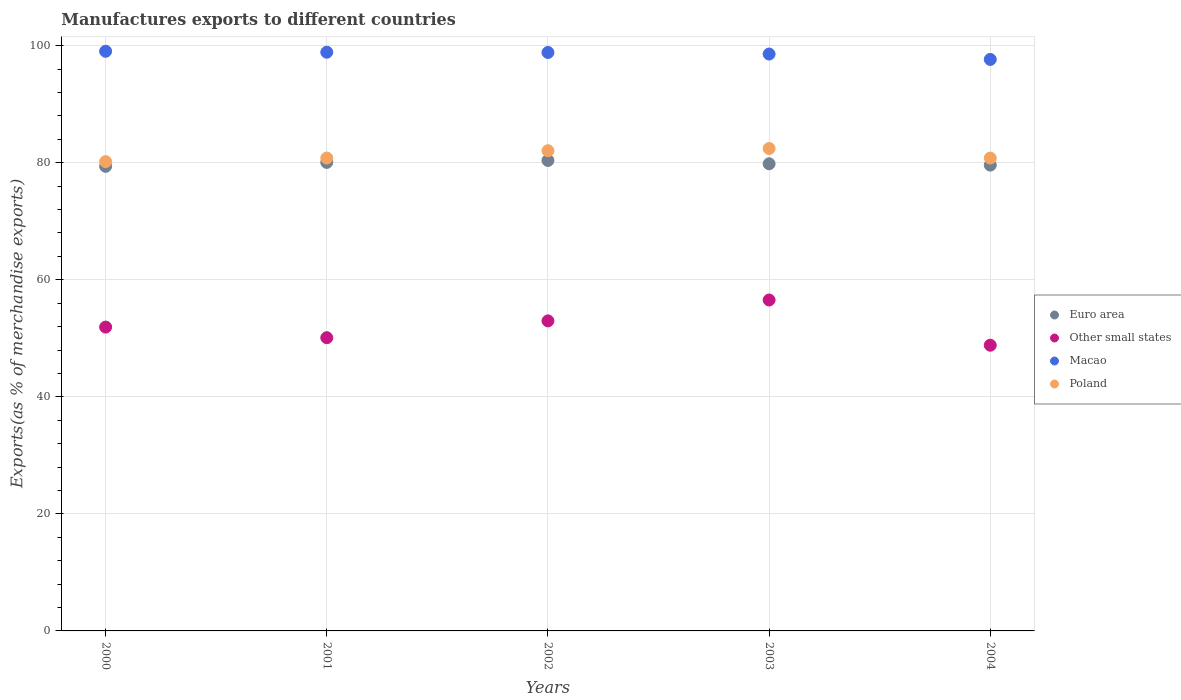Is the number of dotlines equal to the number of legend labels?
Your response must be concise. Yes. What is the percentage of exports to different countries in Macao in 2001?
Your answer should be very brief. 98.89. Across all years, what is the maximum percentage of exports to different countries in Macao?
Keep it short and to the point. 99.05. Across all years, what is the minimum percentage of exports to different countries in Euro area?
Offer a terse response. 79.39. In which year was the percentage of exports to different countries in Euro area maximum?
Provide a succinct answer. 2002. What is the total percentage of exports to different countries in Macao in the graph?
Keep it short and to the point. 493.03. What is the difference between the percentage of exports to different countries in Other small states in 2002 and that in 2004?
Keep it short and to the point. 4.16. What is the difference between the percentage of exports to different countries in Poland in 2004 and the percentage of exports to different countries in Euro area in 2001?
Your response must be concise. 0.74. What is the average percentage of exports to different countries in Macao per year?
Provide a succinct answer. 98.61. In the year 2004, what is the difference between the percentage of exports to different countries in Other small states and percentage of exports to different countries in Macao?
Make the answer very short. -48.84. In how many years, is the percentage of exports to different countries in Other small states greater than 40 %?
Make the answer very short. 5. What is the ratio of the percentage of exports to different countries in Euro area in 2002 to that in 2003?
Provide a succinct answer. 1.01. Is the percentage of exports to different countries in Euro area in 2000 less than that in 2004?
Give a very brief answer. Yes. Is the difference between the percentage of exports to different countries in Other small states in 2002 and 2004 greater than the difference between the percentage of exports to different countries in Macao in 2002 and 2004?
Ensure brevity in your answer.  Yes. What is the difference between the highest and the second highest percentage of exports to different countries in Euro area?
Give a very brief answer. 0.34. What is the difference between the highest and the lowest percentage of exports to different countries in Euro area?
Your answer should be compact. 1.01. In how many years, is the percentage of exports to different countries in Macao greater than the average percentage of exports to different countries in Macao taken over all years?
Give a very brief answer. 3. Is the sum of the percentage of exports to different countries in Macao in 2002 and 2004 greater than the maximum percentage of exports to different countries in Other small states across all years?
Keep it short and to the point. Yes. Is it the case that in every year, the sum of the percentage of exports to different countries in Euro area and percentage of exports to different countries in Macao  is greater than the sum of percentage of exports to different countries in Other small states and percentage of exports to different countries in Poland?
Offer a very short reply. No. Is it the case that in every year, the sum of the percentage of exports to different countries in Poland and percentage of exports to different countries in Macao  is greater than the percentage of exports to different countries in Euro area?
Provide a succinct answer. Yes. Does the percentage of exports to different countries in Other small states monotonically increase over the years?
Your answer should be very brief. No. Is the percentage of exports to different countries in Poland strictly less than the percentage of exports to different countries in Other small states over the years?
Keep it short and to the point. No. How many years are there in the graph?
Make the answer very short. 5. Does the graph contain grids?
Provide a short and direct response. Yes. How many legend labels are there?
Your answer should be very brief. 4. How are the legend labels stacked?
Your answer should be compact. Vertical. What is the title of the graph?
Make the answer very short. Manufactures exports to different countries. Does "Lao PDR" appear as one of the legend labels in the graph?
Give a very brief answer. No. What is the label or title of the X-axis?
Offer a terse response. Years. What is the label or title of the Y-axis?
Provide a succinct answer. Exports(as % of merchandise exports). What is the Exports(as % of merchandise exports) of Euro area in 2000?
Offer a terse response. 79.39. What is the Exports(as % of merchandise exports) in Other small states in 2000?
Your answer should be very brief. 51.92. What is the Exports(as % of merchandise exports) of Macao in 2000?
Make the answer very short. 99.05. What is the Exports(as % of merchandise exports) in Poland in 2000?
Give a very brief answer. 80.19. What is the Exports(as % of merchandise exports) in Euro area in 2001?
Give a very brief answer. 80.06. What is the Exports(as % of merchandise exports) in Other small states in 2001?
Offer a very short reply. 50.11. What is the Exports(as % of merchandise exports) of Macao in 2001?
Ensure brevity in your answer.  98.89. What is the Exports(as % of merchandise exports) of Poland in 2001?
Make the answer very short. 80.81. What is the Exports(as % of merchandise exports) of Euro area in 2002?
Your answer should be very brief. 80.4. What is the Exports(as % of merchandise exports) of Other small states in 2002?
Offer a very short reply. 52.98. What is the Exports(as % of merchandise exports) of Macao in 2002?
Provide a short and direct response. 98.85. What is the Exports(as % of merchandise exports) of Poland in 2002?
Offer a terse response. 82.06. What is the Exports(as % of merchandise exports) of Euro area in 2003?
Your answer should be compact. 79.83. What is the Exports(as % of merchandise exports) of Other small states in 2003?
Offer a very short reply. 56.55. What is the Exports(as % of merchandise exports) in Macao in 2003?
Your answer should be very brief. 98.58. What is the Exports(as % of merchandise exports) in Poland in 2003?
Ensure brevity in your answer.  82.44. What is the Exports(as % of merchandise exports) of Euro area in 2004?
Your response must be concise. 79.6. What is the Exports(as % of merchandise exports) in Other small states in 2004?
Keep it short and to the point. 48.82. What is the Exports(as % of merchandise exports) in Macao in 2004?
Your answer should be very brief. 97.66. What is the Exports(as % of merchandise exports) of Poland in 2004?
Your answer should be very brief. 80.8. Across all years, what is the maximum Exports(as % of merchandise exports) of Euro area?
Give a very brief answer. 80.4. Across all years, what is the maximum Exports(as % of merchandise exports) in Other small states?
Offer a terse response. 56.55. Across all years, what is the maximum Exports(as % of merchandise exports) in Macao?
Give a very brief answer. 99.05. Across all years, what is the maximum Exports(as % of merchandise exports) of Poland?
Provide a succinct answer. 82.44. Across all years, what is the minimum Exports(as % of merchandise exports) of Euro area?
Your response must be concise. 79.39. Across all years, what is the minimum Exports(as % of merchandise exports) in Other small states?
Provide a succinct answer. 48.82. Across all years, what is the minimum Exports(as % of merchandise exports) of Macao?
Ensure brevity in your answer.  97.66. Across all years, what is the minimum Exports(as % of merchandise exports) in Poland?
Provide a short and direct response. 80.19. What is the total Exports(as % of merchandise exports) in Euro area in the graph?
Offer a very short reply. 399.27. What is the total Exports(as % of merchandise exports) of Other small states in the graph?
Your answer should be very brief. 260.38. What is the total Exports(as % of merchandise exports) of Macao in the graph?
Provide a succinct answer. 493.03. What is the total Exports(as % of merchandise exports) of Poland in the graph?
Your answer should be compact. 406.3. What is the difference between the Exports(as % of merchandise exports) in Euro area in 2000 and that in 2001?
Make the answer very short. -0.67. What is the difference between the Exports(as % of merchandise exports) of Other small states in 2000 and that in 2001?
Your answer should be compact. 1.81. What is the difference between the Exports(as % of merchandise exports) in Macao in 2000 and that in 2001?
Your answer should be compact. 0.16. What is the difference between the Exports(as % of merchandise exports) in Poland in 2000 and that in 2001?
Offer a very short reply. -0.62. What is the difference between the Exports(as % of merchandise exports) of Euro area in 2000 and that in 2002?
Offer a terse response. -1.01. What is the difference between the Exports(as % of merchandise exports) in Other small states in 2000 and that in 2002?
Give a very brief answer. -1.06. What is the difference between the Exports(as % of merchandise exports) of Macao in 2000 and that in 2002?
Your response must be concise. 0.2. What is the difference between the Exports(as % of merchandise exports) in Poland in 2000 and that in 2002?
Give a very brief answer. -1.87. What is the difference between the Exports(as % of merchandise exports) in Euro area in 2000 and that in 2003?
Keep it short and to the point. -0.44. What is the difference between the Exports(as % of merchandise exports) in Other small states in 2000 and that in 2003?
Keep it short and to the point. -4.63. What is the difference between the Exports(as % of merchandise exports) in Macao in 2000 and that in 2003?
Provide a succinct answer. 0.47. What is the difference between the Exports(as % of merchandise exports) of Poland in 2000 and that in 2003?
Provide a succinct answer. -2.24. What is the difference between the Exports(as % of merchandise exports) in Euro area in 2000 and that in 2004?
Make the answer very short. -0.21. What is the difference between the Exports(as % of merchandise exports) of Other small states in 2000 and that in 2004?
Your answer should be very brief. 3.1. What is the difference between the Exports(as % of merchandise exports) in Macao in 2000 and that in 2004?
Make the answer very short. 1.39. What is the difference between the Exports(as % of merchandise exports) of Poland in 2000 and that in 2004?
Your answer should be compact. -0.61. What is the difference between the Exports(as % of merchandise exports) in Euro area in 2001 and that in 2002?
Your answer should be very brief. -0.34. What is the difference between the Exports(as % of merchandise exports) of Other small states in 2001 and that in 2002?
Ensure brevity in your answer.  -2.87. What is the difference between the Exports(as % of merchandise exports) in Macao in 2001 and that in 2002?
Keep it short and to the point. 0.04. What is the difference between the Exports(as % of merchandise exports) in Poland in 2001 and that in 2002?
Give a very brief answer. -1.25. What is the difference between the Exports(as % of merchandise exports) in Euro area in 2001 and that in 2003?
Your answer should be compact. 0.24. What is the difference between the Exports(as % of merchandise exports) in Other small states in 2001 and that in 2003?
Offer a very short reply. -6.44. What is the difference between the Exports(as % of merchandise exports) of Macao in 2001 and that in 2003?
Keep it short and to the point. 0.31. What is the difference between the Exports(as % of merchandise exports) of Poland in 2001 and that in 2003?
Your answer should be compact. -1.63. What is the difference between the Exports(as % of merchandise exports) of Euro area in 2001 and that in 2004?
Provide a succinct answer. 0.46. What is the difference between the Exports(as % of merchandise exports) in Other small states in 2001 and that in 2004?
Offer a terse response. 1.29. What is the difference between the Exports(as % of merchandise exports) of Macao in 2001 and that in 2004?
Make the answer very short. 1.23. What is the difference between the Exports(as % of merchandise exports) of Poland in 2001 and that in 2004?
Offer a terse response. 0.01. What is the difference between the Exports(as % of merchandise exports) in Euro area in 2002 and that in 2003?
Offer a very short reply. 0.57. What is the difference between the Exports(as % of merchandise exports) in Other small states in 2002 and that in 2003?
Your answer should be very brief. -3.57. What is the difference between the Exports(as % of merchandise exports) of Macao in 2002 and that in 2003?
Ensure brevity in your answer.  0.27. What is the difference between the Exports(as % of merchandise exports) in Poland in 2002 and that in 2003?
Offer a very short reply. -0.38. What is the difference between the Exports(as % of merchandise exports) of Euro area in 2002 and that in 2004?
Your answer should be compact. 0.8. What is the difference between the Exports(as % of merchandise exports) in Other small states in 2002 and that in 2004?
Offer a very short reply. 4.16. What is the difference between the Exports(as % of merchandise exports) in Macao in 2002 and that in 2004?
Your answer should be very brief. 1.19. What is the difference between the Exports(as % of merchandise exports) in Poland in 2002 and that in 2004?
Keep it short and to the point. 1.26. What is the difference between the Exports(as % of merchandise exports) of Euro area in 2003 and that in 2004?
Offer a terse response. 0.23. What is the difference between the Exports(as % of merchandise exports) of Other small states in 2003 and that in 2004?
Provide a succinct answer. 7.73. What is the difference between the Exports(as % of merchandise exports) in Macao in 2003 and that in 2004?
Your response must be concise. 0.92. What is the difference between the Exports(as % of merchandise exports) of Poland in 2003 and that in 2004?
Your answer should be compact. 1.64. What is the difference between the Exports(as % of merchandise exports) of Euro area in 2000 and the Exports(as % of merchandise exports) of Other small states in 2001?
Offer a terse response. 29.28. What is the difference between the Exports(as % of merchandise exports) in Euro area in 2000 and the Exports(as % of merchandise exports) in Macao in 2001?
Ensure brevity in your answer.  -19.5. What is the difference between the Exports(as % of merchandise exports) in Euro area in 2000 and the Exports(as % of merchandise exports) in Poland in 2001?
Offer a terse response. -1.42. What is the difference between the Exports(as % of merchandise exports) in Other small states in 2000 and the Exports(as % of merchandise exports) in Macao in 2001?
Your answer should be compact. -46.97. What is the difference between the Exports(as % of merchandise exports) of Other small states in 2000 and the Exports(as % of merchandise exports) of Poland in 2001?
Make the answer very short. -28.89. What is the difference between the Exports(as % of merchandise exports) of Macao in 2000 and the Exports(as % of merchandise exports) of Poland in 2001?
Your response must be concise. 18.24. What is the difference between the Exports(as % of merchandise exports) of Euro area in 2000 and the Exports(as % of merchandise exports) of Other small states in 2002?
Offer a very short reply. 26.41. What is the difference between the Exports(as % of merchandise exports) of Euro area in 2000 and the Exports(as % of merchandise exports) of Macao in 2002?
Keep it short and to the point. -19.46. What is the difference between the Exports(as % of merchandise exports) in Euro area in 2000 and the Exports(as % of merchandise exports) in Poland in 2002?
Keep it short and to the point. -2.67. What is the difference between the Exports(as % of merchandise exports) of Other small states in 2000 and the Exports(as % of merchandise exports) of Macao in 2002?
Offer a terse response. -46.93. What is the difference between the Exports(as % of merchandise exports) in Other small states in 2000 and the Exports(as % of merchandise exports) in Poland in 2002?
Give a very brief answer. -30.14. What is the difference between the Exports(as % of merchandise exports) of Macao in 2000 and the Exports(as % of merchandise exports) of Poland in 2002?
Offer a very short reply. 16.99. What is the difference between the Exports(as % of merchandise exports) in Euro area in 2000 and the Exports(as % of merchandise exports) in Other small states in 2003?
Offer a very short reply. 22.84. What is the difference between the Exports(as % of merchandise exports) in Euro area in 2000 and the Exports(as % of merchandise exports) in Macao in 2003?
Your response must be concise. -19.19. What is the difference between the Exports(as % of merchandise exports) in Euro area in 2000 and the Exports(as % of merchandise exports) in Poland in 2003?
Offer a terse response. -3.05. What is the difference between the Exports(as % of merchandise exports) of Other small states in 2000 and the Exports(as % of merchandise exports) of Macao in 2003?
Offer a terse response. -46.66. What is the difference between the Exports(as % of merchandise exports) in Other small states in 2000 and the Exports(as % of merchandise exports) in Poland in 2003?
Your answer should be compact. -30.52. What is the difference between the Exports(as % of merchandise exports) of Macao in 2000 and the Exports(as % of merchandise exports) of Poland in 2003?
Offer a very short reply. 16.62. What is the difference between the Exports(as % of merchandise exports) of Euro area in 2000 and the Exports(as % of merchandise exports) of Other small states in 2004?
Keep it short and to the point. 30.57. What is the difference between the Exports(as % of merchandise exports) of Euro area in 2000 and the Exports(as % of merchandise exports) of Macao in 2004?
Your answer should be very brief. -18.27. What is the difference between the Exports(as % of merchandise exports) in Euro area in 2000 and the Exports(as % of merchandise exports) in Poland in 2004?
Your response must be concise. -1.41. What is the difference between the Exports(as % of merchandise exports) in Other small states in 2000 and the Exports(as % of merchandise exports) in Macao in 2004?
Provide a short and direct response. -45.74. What is the difference between the Exports(as % of merchandise exports) in Other small states in 2000 and the Exports(as % of merchandise exports) in Poland in 2004?
Provide a succinct answer. -28.88. What is the difference between the Exports(as % of merchandise exports) in Macao in 2000 and the Exports(as % of merchandise exports) in Poland in 2004?
Provide a succinct answer. 18.25. What is the difference between the Exports(as % of merchandise exports) in Euro area in 2001 and the Exports(as % of merchandise exports) in Other small states in 2002?
Offer a terse response. 27.08. What is the difference between the Exports(as % of merchandise exports) in Euro area in 2001 and the Exports(as % of merchandise exports) in Macao in 2002?
Your response must be concise. -18.79. What is the difference between the Exports(as % of merchandise exports) in Euro area in 2001 and the Exports(as % of merchandise exports) in Poland in 2002?
Ensure brevity in your answer.  -2. What is the difference between the Exports(as % of merchandise exports) of Other small states in 2001 and the Exports(as % of merchandise exports) of Macao in 2002?
Your answer should be compact. -48.74. What is the difference between the Exports(as % of merchandise exports) in Other small states in 2001 and the Exports(as % of merchandise exports) in Poland in 2002?
Offer a terse response. -31.95. What is the difference between the Exports(as % of merchandise exports) of Macao in 2001 and the Exports(as % of merchandise exports) of Poland in 2002?
Your response must be concise. 16.83. What is the difference between the Exports(as % of merchandise exports) of Euro area in 2001 and the Exports(as % of merchandise exports) of Other small states in 2003?
Ensure brevity in your answer.  23.51. What is the difference between the Exports(as % of merchandise exports) in Euro area in 2001 and the Exports(as % of merchandise exports) in Macao in 2003?
Offer a very short reply. -18.52. What is the difference between the Exports(as % of merchandise exports) in Euro area in 2001 and the Exports(as % of merchandise exports) in Poland in 2003?
Provide a succinct answer. -2.38. What is the difference between the Exports(as % of merchandise exports) of Other small states in 2001 and the Exports(as % of merchandise exports) of Macao in 2003?
Provide a short and direct response. -48.47. What is the difference between the Exports(as % of merchandise exports) of Other small states in 2001 and the Exports(as % of merchandise exports) of Poland in 2003?
Ensure brevity in your answer.  -32.33. What is the difference between the Exports(as % of merchandise exports) in Macao in 2001 and the Exports(as % of merchandise exports) in Poland in 2003?
Provide a succinct answer. 16.45. What is the difference between the Exports(as % of merchandise exports) in Euro area in 2001 and the Exports(as % of merchandise exports) in Other small states in 2004?
Offer a very short reply. 31.24. What is the difference between the Exports(as % of merchandise exports) in Euro area in 2001 and the Exports(as % of merchandise exports) in Macao in 2004?
Ensure brevity in your answer.  -17.6. What is the difference between the Exports(as % of merchandise exports) of Euro area in 2001 and the Exports(as % of merchandise exports) of Poland in 2004?
Provide a short and direct response. -0.74. What is the difference between the Exports(as % of merchandise exports) in Other small states in 2001 and the Exports(as % of merchandise exports) in Macao in 2004?
Offer a terse response. -47.55. What is the difference between the Exports(as % of merchandise exports) in Other small states in 2001 and the Exports(as % of merchandise exports) in Poland in 2004?
Keep it short and to the point. -30.69. What is the difference between the Exports(as % of merchandise exports) in Macao in 2001 and the Exports(as % of merchandise exports) in Poland in 2004?
Offer a very short reply. 18.09. What is the difference between the Exports(as % of merchandise exports) of Euro area in 2002 and the Exports(as % of merchandise exports) of Other small states in 2003?
Give a very brief answer. 23.85. What is the difference between the Exports(as % of merchandise exports) in Euro area in 2002 and the Exports(as % of merchandise exports) in Macao in 2003?
Your answer should be compact. -18.18. What is the difference between the Exports(as % of merchandise exports) in Euro area in 2002 and the Exports(as % of merchandise exports) in Poland in 2003?
Your response must be concise. -2.04. What is the difference between the Exports(as % of merchandise exports) of Other small states in 2002 and the Exports(as % of merchandise exports) of Macao in 2003?
Make the answer very short. -45.6. What is the difference between the Exports(as % of merchandise exports) in Other small states in 2002 and the Exports(as % of merchandise exports) in Poland in 2003?
Ensure brevity in your answer.  -29.46. What is the difference between the Exports(as % of merchandise exports) in Macao in 2002 and the Exports(as % of merchandise exports) in Poland in 2003?
Provide a succinct answer. 16.41. What is the difference between the Exports(as % of merchandise exports) in Euro area in 2002 and the Exports(as % of merchandise exports) in Other small states in 2004?
Offer a very short reply. 31.58. What is the difference between the Exports(as % of merchandise exports) in Euro area in 2002 and the Exports(as % of merchandise exports) in Macao in 2004?
Ensure brevity in your answer.  -17.26. What is the difference between the Exports(as % of merchandise exports) of Euro area in 2002 and the Exports(as % of merchandise exports) of Poland in 2004?
Keep it short and to the point. -0.4. What is the difference between the Exports(as % of merchandise exports) of Other small states in 2002 and the Exports(as % of merchandise exports) of Macao in 2004?
Your answer should be very brief. -44.68. What is the difference between the Exports(as % of merchandise exports) in Other small states in 2002 and the Exports(as % of merchandise exports) in Poland in 2004?
Your answer should be very brief. -27.82. What is the difference between the Exports(as % of merchandise exports) in Macao in 2002 and the Exports(as % of merchandise exports) in Poland in 2004?
Offer a very short reply. 18.05. What is the difference between the Exports(as % of merchandise exports) of Euro area in 2003 and the Exports(as % of merchandise exports) of Other small states in 2004?
Offer a very short reply. 31. What is the difference between the Exports(as % of merchandise exports) of Euro area in 2003 and the Exports(as % of merchandise exports) of Macao in 2004?
Your answer should be compact. -17.83. What is the difference between the Exports(as % of merchandise exports) in Euro area in 2003 and the Exports(as % of merchandise exports) in Poland in 2004?
Provide a short and direct response. -0.98. What is the difference between the Exports(as % of merchandise exports) in Other small states in 2003 and the Exports(as % of merchandise exports) in Macao in 2004?
Provide a succinct answer. -41.11. What is the difference between the Exports(as % of merchandise exports) of Other small states in 2003 and the Exports(as % of merchandise exports) of Poland in 2004?
Offer a terse response. -24.25. What is the difference between the Exports(as % of merchandise exports) in Macao in 2003 and the Exports(as % of merchandise exports) in Poland in 2004?
Offer a very short reply. 17.78. What is the average Exports(as % of merchandise exports) in Euro area per year?
Your answer should be compact. 79.85. What is the average Exports(as % of merchandise exports) in Other small states per year?
Ensure brevity in your answer.  52.08. What is the average Exports(as % of merchandise exports) of Macao per year?
Your response must be concise. 98.61. What is the average Exports(as % of merchandise exports) of Poland per year?
Your answer should be very brief. 81.26. In the year 2000, what is the difference between the Exports(as % of merchandise exports) in Euro area and Exports(as % of merchandise exports) in Other small states?
Your response must be concise. 27.47. In the year 2000, what is the difference between the Exports(as % of merchandise exports) of Euro area and Exports(as % of merchandise exports) of Macao?
Give a very brief answer. -19.66. In the year 2000, what is the difference between the Exports(as % of merchandise exports) in Euro area and Exports(as % of merchandise exports) in Poland?
Keep it short and to the point. -0.8. In the year 2000, what is the difference between the Exports(as % of merchandise exports) in Other small states and Exports(as % of merchandise exports) in Macao?
Keep it short and to the point. -47.13. In the year 2000, what is the difference between the Exports(as % of merchandise exports) of Other small states and Exports(as % of merchandise exports) of Poland?
Your answer should be very brief. -28.27. In the year 2000, what is the difference between the Exports(as % of merchandise exports) of Macao and Exports(as % of merchandise exports) of Poland?
Make the answer very short. 18.86. In the year 2001, what is the difference between the Exports(as % of merchandise exports) of Euro area and Exports(as % of merchandise exports) of Other small states?
Ensure brevity in your answer.  29.95. In the year 2001, what is the difference between the Exports(as % of merchandise exports) in Euro area and Exports(as % of merchandise exports) in Macao?
Your answer should be very brief. -18.83. In the year 2001, what is the difference between the Exports(as % of merchandise exports) in Euro area and Exports(as % of merchandise exports) in Poland?
Your response must be concise. -0.75. In the year 2001, what is the difference between the Exports(as % of merchandise exports) of Other small states and Exports(as % of merchandise exports) of Macao?
Provide a short and direct response. -48.78. In the year 2001, what is the difference between the Exports(as % of merchandise exports) of Other small states and Exports(as % of merchandise exports) of Poland?
Your answer should be compact. -30.7. In the year 2001, what is the difference between the Exports(as % of merchandise exports) of Macao and Exports(as % of merchandise exports) of Poland?
Your response must be concise. 18.08. In the year 2002, what is the difference between the Exports(as % of merchandise exports) in Euro area and Exports(as % of merchandise exports) in Other small states?
Your answer should be compact. 27.42. In the year 2002, what is the difference between the Exports(as % of merchandise exports) of Euro area and Exports(as % of merchandise exports) of Macao?
Your answer should be compact. -18.45. In the year 2002, what is the difference between the Exports(as % of merchandise exports) of Euro area and Exports(as % of merchandise exports) of Poland?
Your answer should be compact. -1.66. In the year 2002, what is the difference between the Exports(as % of merchandise exports) in Other small states and Exports(as % of merchandise exports) in Macao?
Offer a terse response. -45.87. In the year 2002, what is the difference between the Exports(as % of merchandise exports) in Other small states and Exports(as % of merchandise exports) in Poland?
Give a very brief answer. -29.08. In the year 2002, what is the difference between the Exports(as % of merchandise exports) of Macao and Exports(as % of merchandise exports) of Poland?
Offer a terse response. 16.79. In the year 2003, what is the difference between the Exports(as % of merchandise exports) of Euro area and Exports(as % of merchandise exports) of Other small states?
Offer a terse response. 23.27. In the year 2003, what is the difference between the Exports(as % of merchandise exports) of Euro area and Exports(as % of merchandise exports) of Macao?
Your answer should be very brief. -18.75. In the year 2003, what is the difference between the Exports(as % of merchandise exports) of Euro area and Exports(as % of merchandise exports) of Poland?
Offer a terse response. -2.61. In the year 2003, what is the difference between the Exports(as % of merchandise exports) in Other small states and Exports(as % of merchandise exports) in Macao?
Your answer should be very brief. -42.03. In the year 2003, what is the difference between the Exports(as % of merchandise exports) of Other small states and Exports(as % of merchandise exports) of Poland?
Your response must be concise. -25.89. In the year 2003, what is the difference between the Exports(as % of merchandise exports) in Macao and Exports(as % of merchandise exports) in Poland?
Keep it short and to the point. 16.14. In the year 2004, what is the difference between the Exports(as % of merchandise exports) of Euro area and Exports(as % of merchandise exports) of Other small states?
Your answer should be compact. 30.78. In the year 2004, what is the difference between the Exports(as % of merchandise exports) in Euro area and Exports(as % of merchandise exports) in Macao?
Your response must be concise. -18.06. In the year 2004, what is the difference between the Exports(as % of merchandise exports) in Euro area and Exports(as % of merchandise exports) in Poland?
Offer a very short reply. -1.2. In the year 2004, what is the difference between the Exports(as % of merchandise exports) of Other small states and Exports(as % of merchandise exports) of Macao?
Keep it short and to the point. -48.84. In the year 2004, what is the difference between the Exports(as % of merchandise exports) of Other small states and Exports(as % of merchandise exports) of Poland?
Provide a short and direct response. -31.98. In the year 2004, what is the difference between the Exports(as % of merchandise exports) of Macao and Exports(as % of merchandise exports) of Poland?
Your response must be concise. 16.86. What is the ratio of the Exports(as % of merchandise exports) of Euro area in 2000 to that in 2001?
Your answer should be very brief. 0.99. What is the ratio of the Exports(as % of merchandise exports) of Other small states in 2000 to that in 2001?
Offer a very short reply. 1.04. What is the ratio of the Exports(as % of merchandise exports) in Euro area in 2000 to that in 2002?
Offer a very short reply. 0.99. What is the ratio of the Exports(as % of merchandise exports) in Other small states in 2000 to that in 2002?
Ensure brevity in your answer.  0.98. What is the ratio of the Exports(as % of merchandise exports) of Macao in 2000 to that in 2002?
Keep it short and to the point. 1. What is the ratio of the Exports(as % of merchandise exports) of Poland in 2000 to that in 2002?
Offer a terse response. 0.98. What is the ratio of the Exports(as % of merchandise exports) of Euro area in 2000 to that in 2003?
Provide a succinct answer. 0.99. What is the ratio of the Exports(as % of merchandise exports) of Other small states in 2000 to that in 2003?
Offer a terse response. 0.92. What is the ratio of the Exports(as % of merchandise exports) in Macao in 2000 to that in 2003?
Offer a terse response. 1. What is the ratio of the Exports(as % of merchandise exports) of Poland in 2000 to that in 2003?
Offer a very short reply. 0.97. What is the ratio of the Exports(as % of merchandise exports) of Euro area in 2000 to that in 2004?
Provide a succinct answer. 1. What is the ratio of the Exports(as % of merchandise exports) of Other small states in 2000 to that in 2004?
Your answer should be very brief. 1.06. What is the ratio of the Exports(as % of merchandise exports) of Macao in 2000 to that in 2004?
Ensure brevity in your answer.  1.01. What is the ratio of the Exports(as % of merchandise exports) in Poland in 2000 to that in 2004?
Your answer should be compact. 0.99. What is the ratio of the Exports(as % of merchandise exports) in Euro area in 2001 to that in 2002?
Make the answer very short. 1. What is the ratio of the Exports(as % of merchandise exports) of Other small states in 2001 to that in 2002?
Your answer should be compact. 0.95. What is the ratio of the Exports(as % of merchandise exports) of Poland in 2001 to that in 2002?
Provide a short and direct response. 0.98. What is the ratio of the Exports(as % of merchandise exports) in Other small states in 2001 to that in 2003?
Your answer should be very brief. 0.89. What is the ratio of the Exports(as % of merchandise exports) in Macao in 2001 to that in 2003?
Ensure brevity in your answer.  1. What is the ratio of the Exports(as % of merchandise exports) in Poland in 2001 to that in 2003?
Make the answer very short. 0.98. What is the ratio of the Exports(as % of merchandise exports) in Other small states in 2001 to that in 2004?
Offer a very short reply. 1.03. What is the ratio of the Exports(as % of merchandise exports) in Macao in 2001 to that in 2004?
Keep it short and to the point. 1.01. What is the ratio of the Exports(as % of merchandise exports) in Poland in 2001 to that in 2004?
Your answer should be very brief. 1. What is the ratio of the Exports(as % of merchandise exports) in Euro area in 2002 to that in 2003?
Your answer should be very brief. 1.01. What is the ratio of the Exports(as % of merchandise exports) of Other small states in 2002 to that in 2003?
Make the answer very short. 0.94. What is the ratio of the Exports(as % of merchandise exports) of Macao in 2002 to that in 2003?
Your answer should be compact. 1. What is the ratio of the Exports(as % of merchandise exports) in Poland in 2002 to that in 2003?
Your response must be concise. 1. What is the ratio of the Exports(as % of merchandise exports) of Other small states in 2002 to that in 2004?
Provide a succinct answer. 1.09. What is the ratio of the Exports(as % of merchandise exports) of Macao in 2002 to that in 2004?
Your response must be concise. 1.01. What is the ratio of the Exports(as % of merchandise exports) of Poland in 2002 to that in 2004?
Provide a succinct answer. 1.02. What is the ratio of the Exports(as % of merchandise exports) of Other small states in 2003 to that in 2004?
Offer a terse response. 1.16. What is the ratio of the Exports(as % of merchandise exports) in Macao in 2003 to that in 2004?
Your response must be concise. 1.01. What is the ratio of the Exports(as % of merchandise exports) of Poland in 2003 to that in 2004?
Your answer should be compact. 1.02. What is the difference between the highest and the second highest Exports(as % of merchandise exports) in Euro area?
Ensure brevity in your answer.  0.34. What is the difference between the highest and the second highest Exports(as % of merchandise exports) of Other small states?
Offer a very short reply. 3.57. What is the difference between the highest and the second highest Exports(as % of merchandise exports) in Macao?
Make the answer very short. 0.16. What is the difference between the highest and the second highest Exports(as % of merchandise exports) in Poland?
Your response must be concise. 0.38. What is the difference between the highest and the lowest Exports(as % of merchandise exports) of Euro area?
Offer a terse response. 1.01. What is the difference between the highest and the lowest Exports(as % of merchandise exports) of Other small states?
Your response must be concise. 7.73. What is the difference between the highest and the lowest Exports(as % of merchandise exports) in Macao?
Provide a succinct answer. 1.39. What is the difference between the highest and the lowest Exports(as % of merchandise exports) in Poland?
Provide a short and direct response. 2.24. 